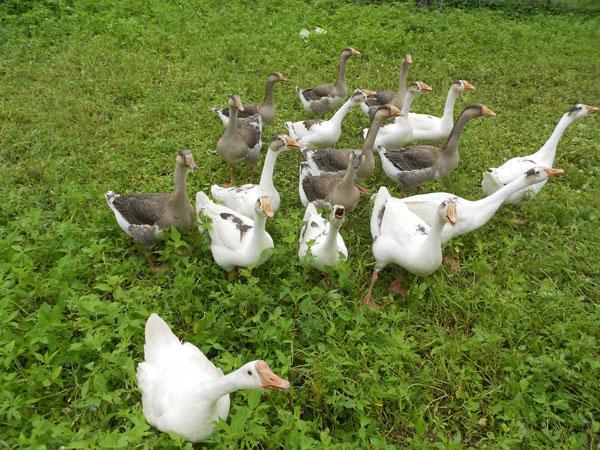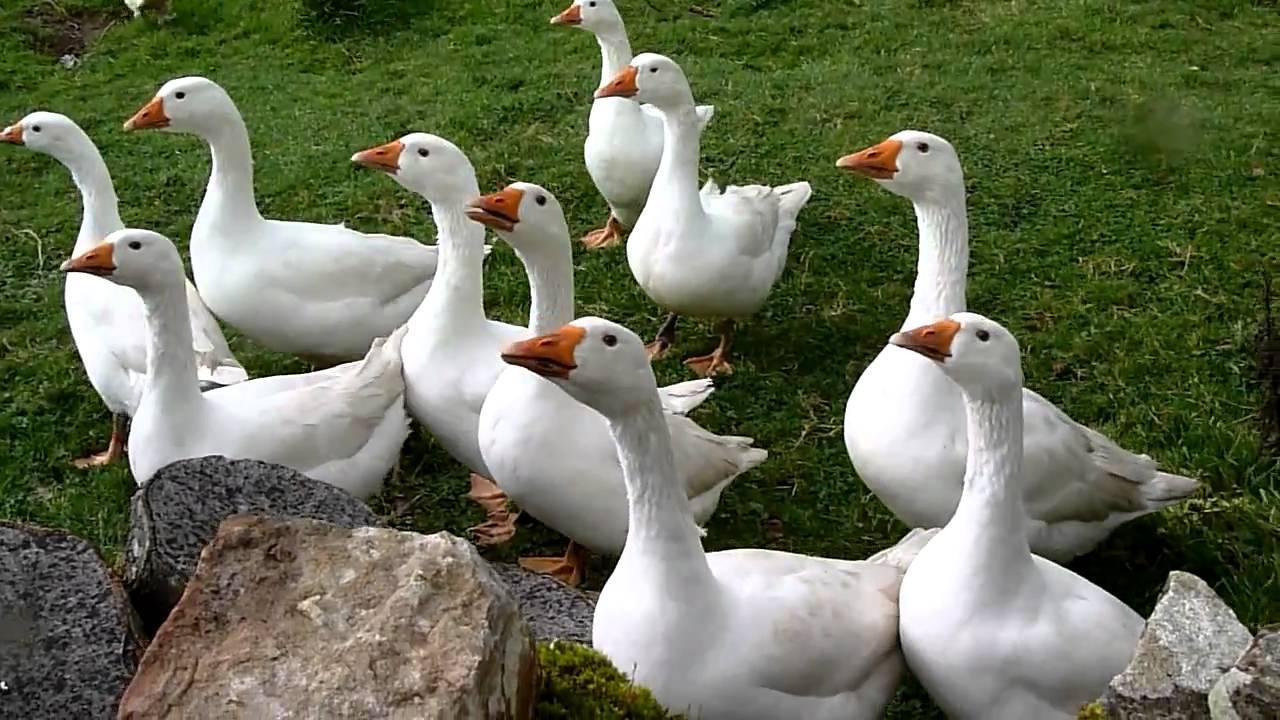The first image is the image on the left, the second image is the image on the right. For the images displayed, is the sentence "One of the images show geese that are all facing left." factually correct? Answer yes or no. Yes. 